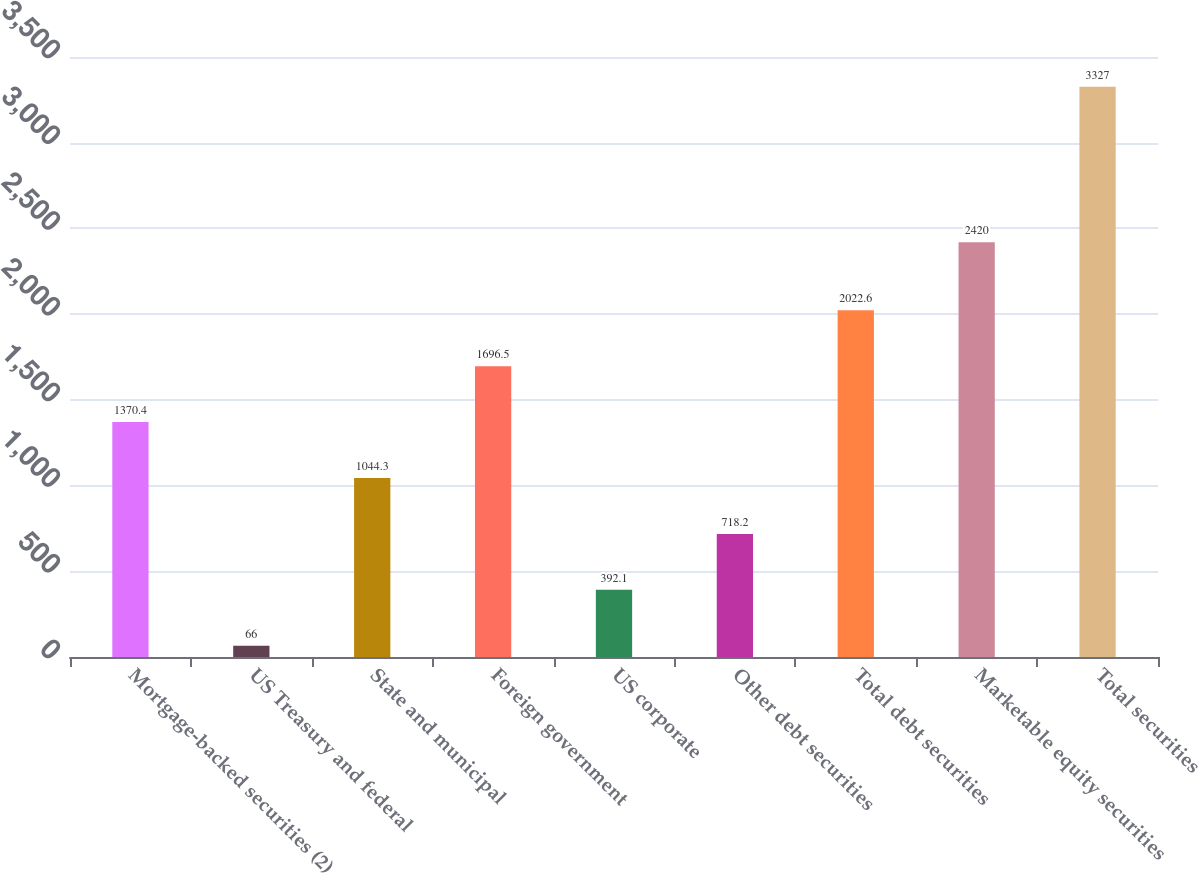Convert chart. <chart><loc_0><loc_0><loc_500><loc_500><bar_chart><fcel>Mortgage-backed securities (2)<fcel>US Treasury and federal<fcel>State and municipal<fcel>Foreign government<fcel>US corporate<fcel>Other debt securities<fcel>Total debt securities<fcel>Marketable equity securities<fcel>Total securities<nl><fcel>1370.4<fcel>66<fcel>1044.3<fcel>1696.5<fcel>392.1<fcel>718.2<fcel>2022.6<fcel>2420<fcel>3327<nl></chart> 